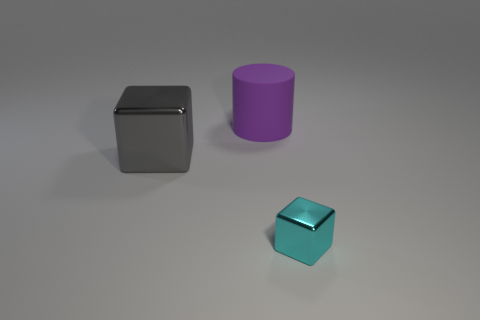Add 2 small purple metal cylinders. How many objects exist? 5 Subtract all cylinders. How many objects are left? 2 Subtract 0 cyan cylinders. How many objects are left? 3 Subtract all objects. Subtract all tiny red things. How many objects are left? 0 Add 1 big matte things. How many big matte things are left? 2 Add 2 big blue blocks. How many big blue blocks exist? 2 